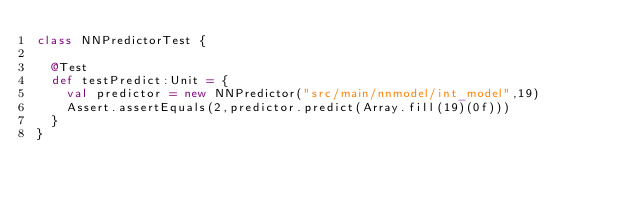Convert code to text. <code><loc_0><loc_0><loc_500><loc_500><_Scala_>class NNPredictorTest {

  @Test
  def testPredict:Unit = {
    val predictor = new NNPredictor("src/main/nnmodel/int_model",19)
    Assert.assertEquals(2,predictor.predict(Array.fill(19)(0f)))
  }
}
</code> 